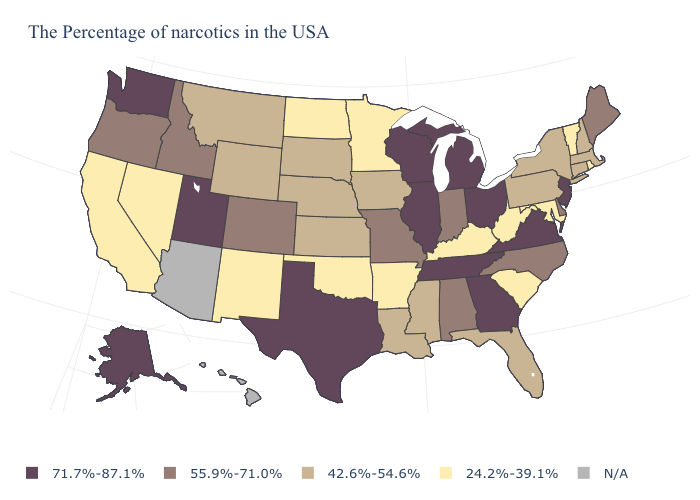What is the highest value in states that border Oregon?
Quick response, please. 71.7%-87.1%. Among the states that border Rhode Island , which have the highest value?
Be succinct. Massachusetts, Connecticut. Does Illinois have the lowest value in the MidWest?
Concise answer only. No. What is the value of Texas?
Keep it brief. 71.7%-87.1%. Name the states that have a value in the range 42.6%-54.6%?
Concise answer only. Massachusetts, New Hampshire, Connecticut, New York, Pennsylvania, Florida, Mississippi, Louisiana, Iowa, Kansas, Nebraska, South Dakota, Wyoming, Montana. Does the first symbol in the legend represent the smallest category?
Keep it brief. No. Does the map have missing data?
Concise answer only. Yes. What is the value of Vermont?
Answer briefly. 24.2%-39.1%. Does the first symbol in the legend represent the smallest category?
Quick response, please. No. Does South Dakota have the lowest value in the USA?
Quick response, please. No. What is the value of Virginia?
Keep it brief. 71.7%-87.1%. How many symbols are there in the legend?
Short answer required. 5. 